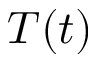<formula> <loc_0><loc_0><loc_500><loc_500>T ( t )</formula> 